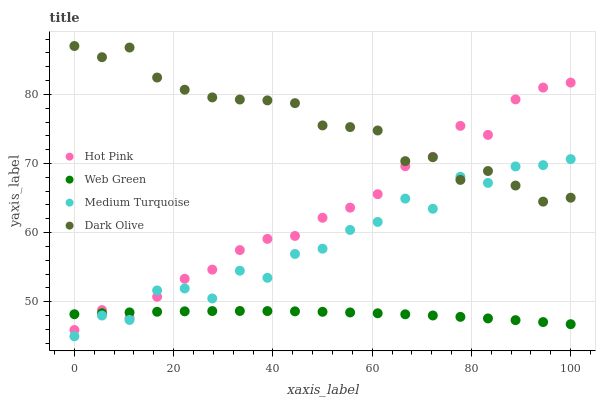Does Web Green have the minimum area under the curve?
Answer yes or no. Yes. Does Dark Olive have the maximum area under the curve?
Answer yes or no. Yes. Does Hot Pink have the minimum area under the curve?
Answer yes or no. No. Does Hot Pink have the maximum area under the curve?
Answer yes or no. No. Is Web Green the smoothest?
Answer yes or no. Yes. Is Medium Turquoise the roughest?
Answer yes or no. Yes. Is Hot Pink the smoothest?
Answer yes or no. No. Is Hot Pink the roughest?
Answer yes or no. No. Does Medium Turquoise have the lowest value?
Answer yes or no. Yes. Does Hot Pink have the lowest value?
Answer yes or no. No. Does Dark Olive have the highest value?
Answer yes or no. Yes. Does Hot Pink have the highest value?
Answer yes or no. No. Is Web Green less than Dark Olive?
Answer yes or no. Yes. Is Dark Olive greater than Web Green?
Answer yes or no. Yes. Does Dark Olive intersect Hot Pink?
Answer yes or no. Yes. Is Dark Olive less than Hot Pink?
Answer yes or no. No. Is Dark Olive greater than Hot Pink?
Answer yes or no. No. Does Web Green intersect Dark Olive?
Answer yes or no. No. 